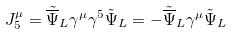Convert formula to latex. <formula><loc_0><loc_0><loc_500><loc_500>J _ { 5 } ^ { \mu } = { \tilde { \overline { \Psi } } } _ { L } \gamma ^ { \mu } \gamma ^ { 5 } \tilde { \Psi } _ { L } = - { \tilde { \overline { \Psi } } } _ { L } \gamma ^ { \mu } \tilde { \Psi } _ { L }</formula> 